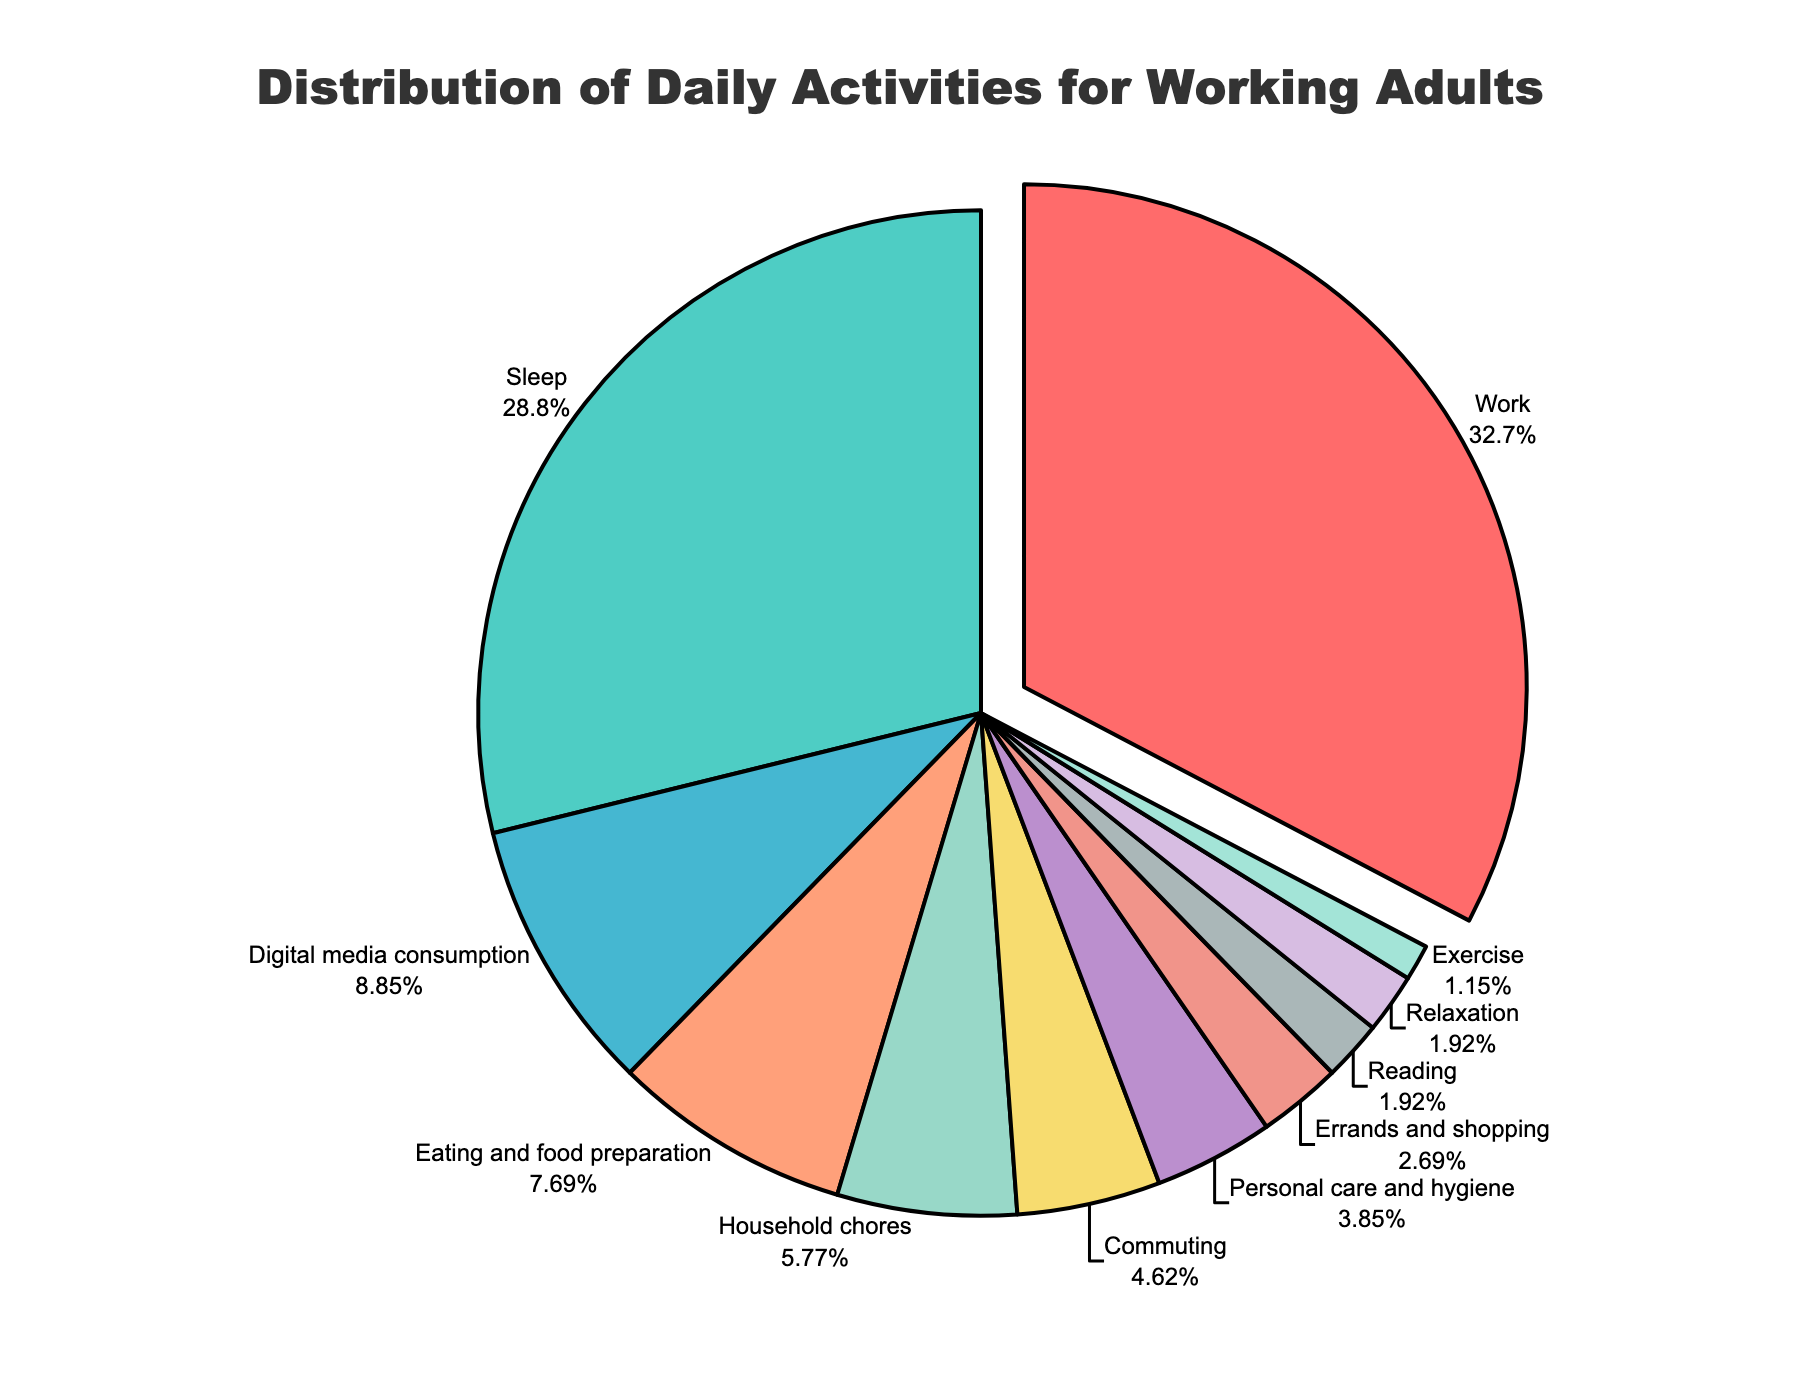Which activity takes up the largest proportion of time? By examining the pie chart, we see that the largest segment is labeled 'Work'. Thus, 'Work' takes up the largest proportion of time.
Answer: Work How much more time is spent on 'Work' compared to 'Sleep'? According to the chart, 'Work' takes 8.5 hours, and 'Sleep' takes 7.5 hours. The difference is 8.5 - 7.5 = 1 hour more.
Answer: 1 hour What is the total percentage of time spent on 'Commuting' and 'Household chores'? 'Commuting' and 'Household chores' are represented by percentages in the pie chart. Summing them up, 5% (Commuting) + 6.2% (Household chores) = 11.2%.
Answer: 11.2% What activity takes up the least amount of time? Visually inspecting the pie chart, the smallest segment is labeled 'Exercise'. Therefore, 'Exercise' takes up the least amount of time.
Answer: Exercise How does the time spent on 'Digital media consumption' compare to 'Eating and food preparation'? We observe the pie chart shows 'Digital media consumption' at 9.7% and 'Eating and food preparation' at 8.4%. Hence, more time is spent on 'Digital media consumption' than on 'Eating and food preparation'.
Answer: Digital media consumption What is the combined percentage of time spent on 'Personal care and hygiene', 'Reading', and 'Errands and shopping'? By adding the percentages shown in the pie chart for these activities: 4.2% (Personal care and hygiene) + 2.1% (Reading) + 3.0% (Errands and shopping) = 9.3%.
Answer: 9.3% What is the difference in time spent on 'Sleep' and all leisure activities ('Digital media consumption', 'Reading', and 'Relaxation')? 'Sleep' takes 7.5 hours. Leisure activities sum up to 2.3 (Digital media consumption) + 0.5 (Reading) + 0.5 (Relaxation) = 3.3 hours. The difference is 7.5 - 3.3 = 4.2 hours.
Answer: 4.2 hours What proportion of the day is spent on activities other than 'Work' and 'Sleep'? Total day hours are 24. 'Work' and 'Sleep' together account for 16 hours (7.5 + 8.5). So, 24 - 16 = 8 hours. This is 8 / 24 * 100 = 33.3%.
Answer: 33.3% What percentage of the total time is spent on 'Exercise'? The pie chart shows that 'Exercise' occupies 1.2% of the total time.
Answer: 1.2% Which activity has a segment pulled out from the rest? The pie chart visually highlights one segment by pulling it out, which is labeled 'Work'.
Answer: Work 